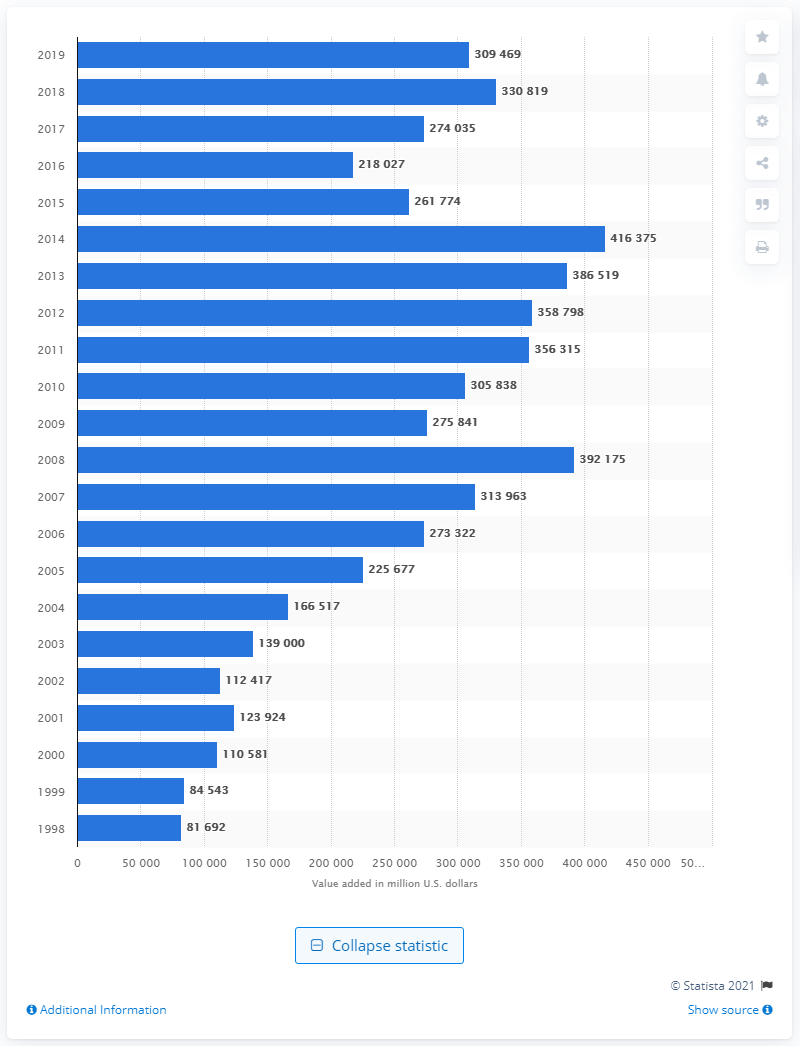Draw attention to some important aspects in this diagram. In 1998, the value of the mining industry was 81,692 dollars. In 2019, the value added by the mining industry was 309,469... 